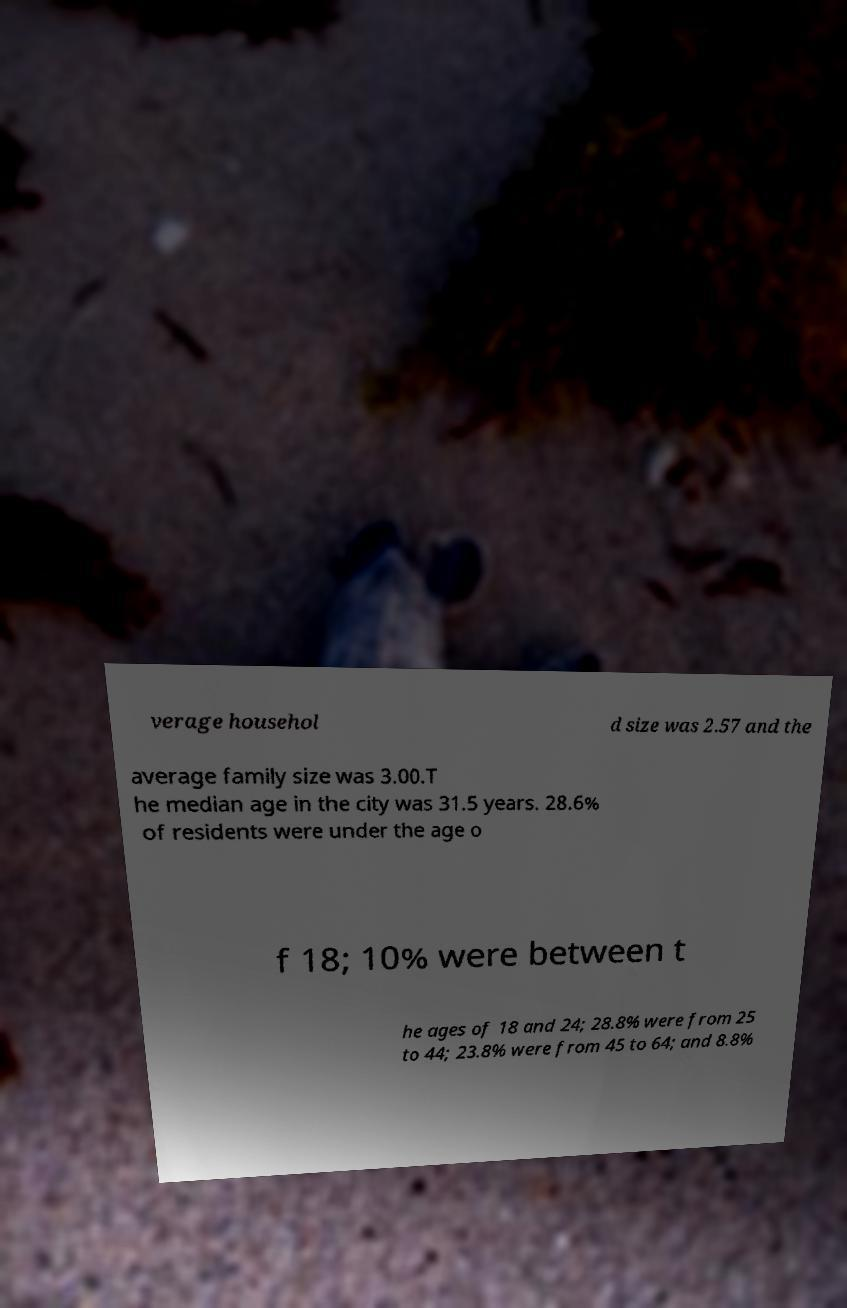I need the written content from this picture converted into text. Can you do that? verage househol d size was 2.57 and the average family size was 3.00.T he median age in the city was 31.5 years. 28.6% of residents were under the age o f 18; 10% were between t he ages of 18 and 24; 28.8% were from 25 to 44; 23.8% were from 45 to 64; and 8.8% 